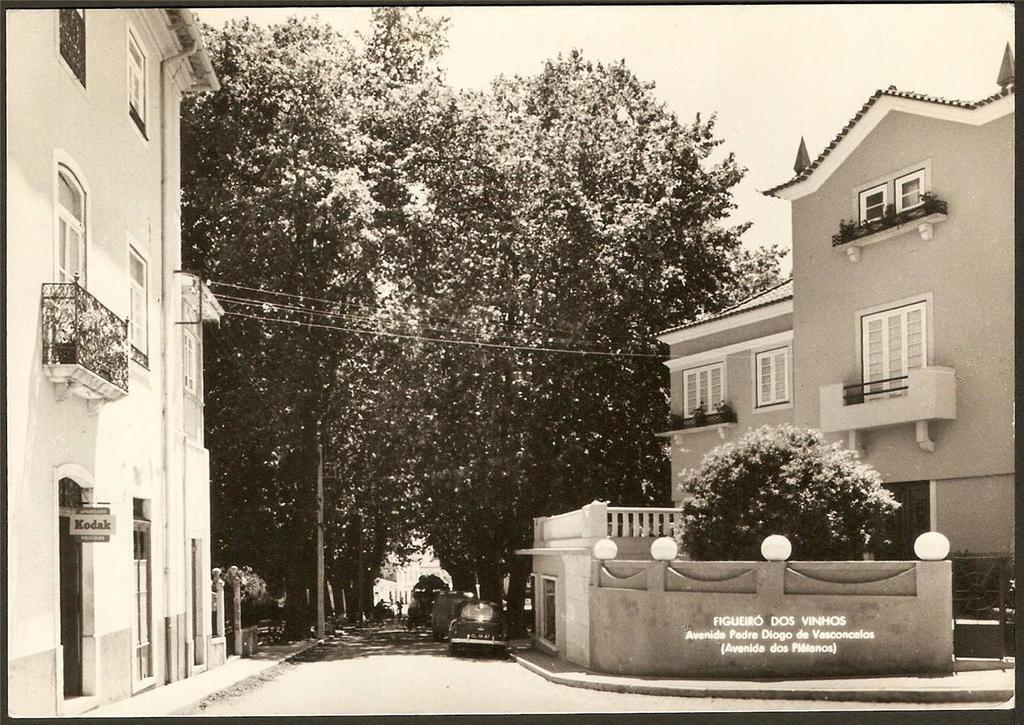What is the color scheme of the image? The image is black and white. What can be seen on the road in the image? There are vehicles on the road in the image. What is visible on both sides of the image? There are buildings on the right side and left side of the image. What type of natural scenery can be seen in the background of the image? There are trees in the background of the image. What type of sugar is being used during the recess in the image? There is no recess or sugar present in the image; it features vehicles on the road and buildings on both sides. What type of flight can be seen taking off in the image? There is no flight present in the image; it is a black and white image of vehicles, buildings, and trees. 